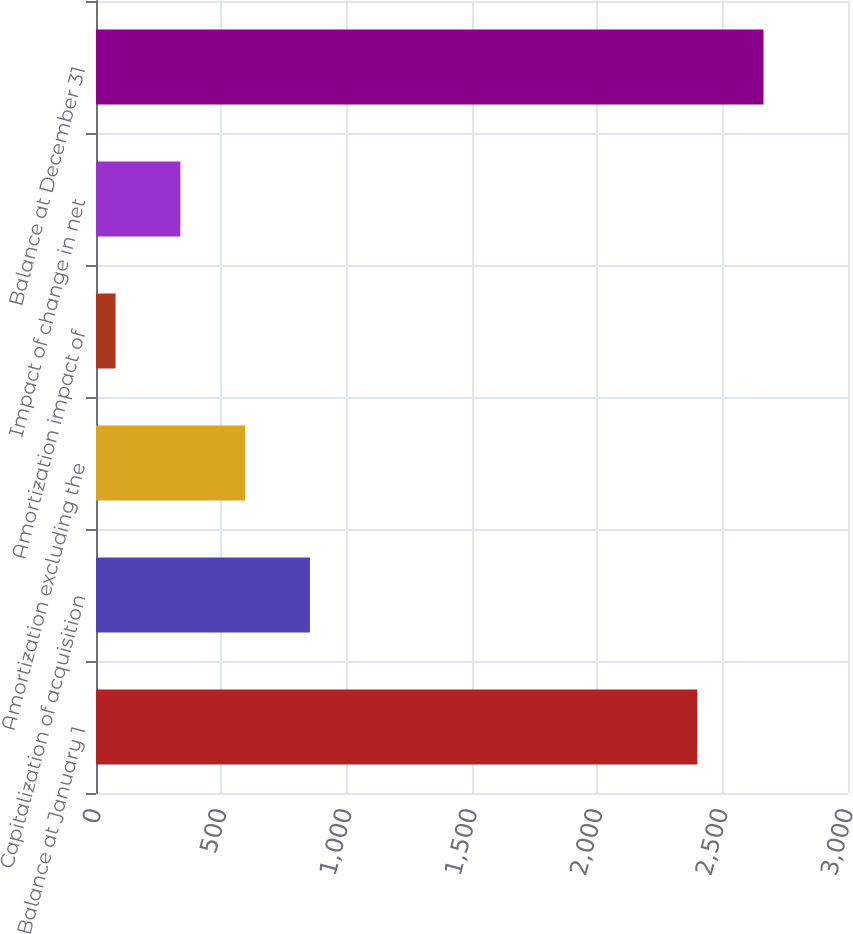<chart> <loc_0><loc_0><loc_500><loc_500><bar_chart><fcel>Balance at January 1<fcel>Capitalization of acquisition<fcel>Amortization excluding the<fcel>Amortization impact of<fcel>Impact of change in net<fcel>Balance at December 31<nl><fcel>2399<fcel>853.5<fcel>595<fcel>78<fcel>336.5<fcel>2663<nl></chart> 